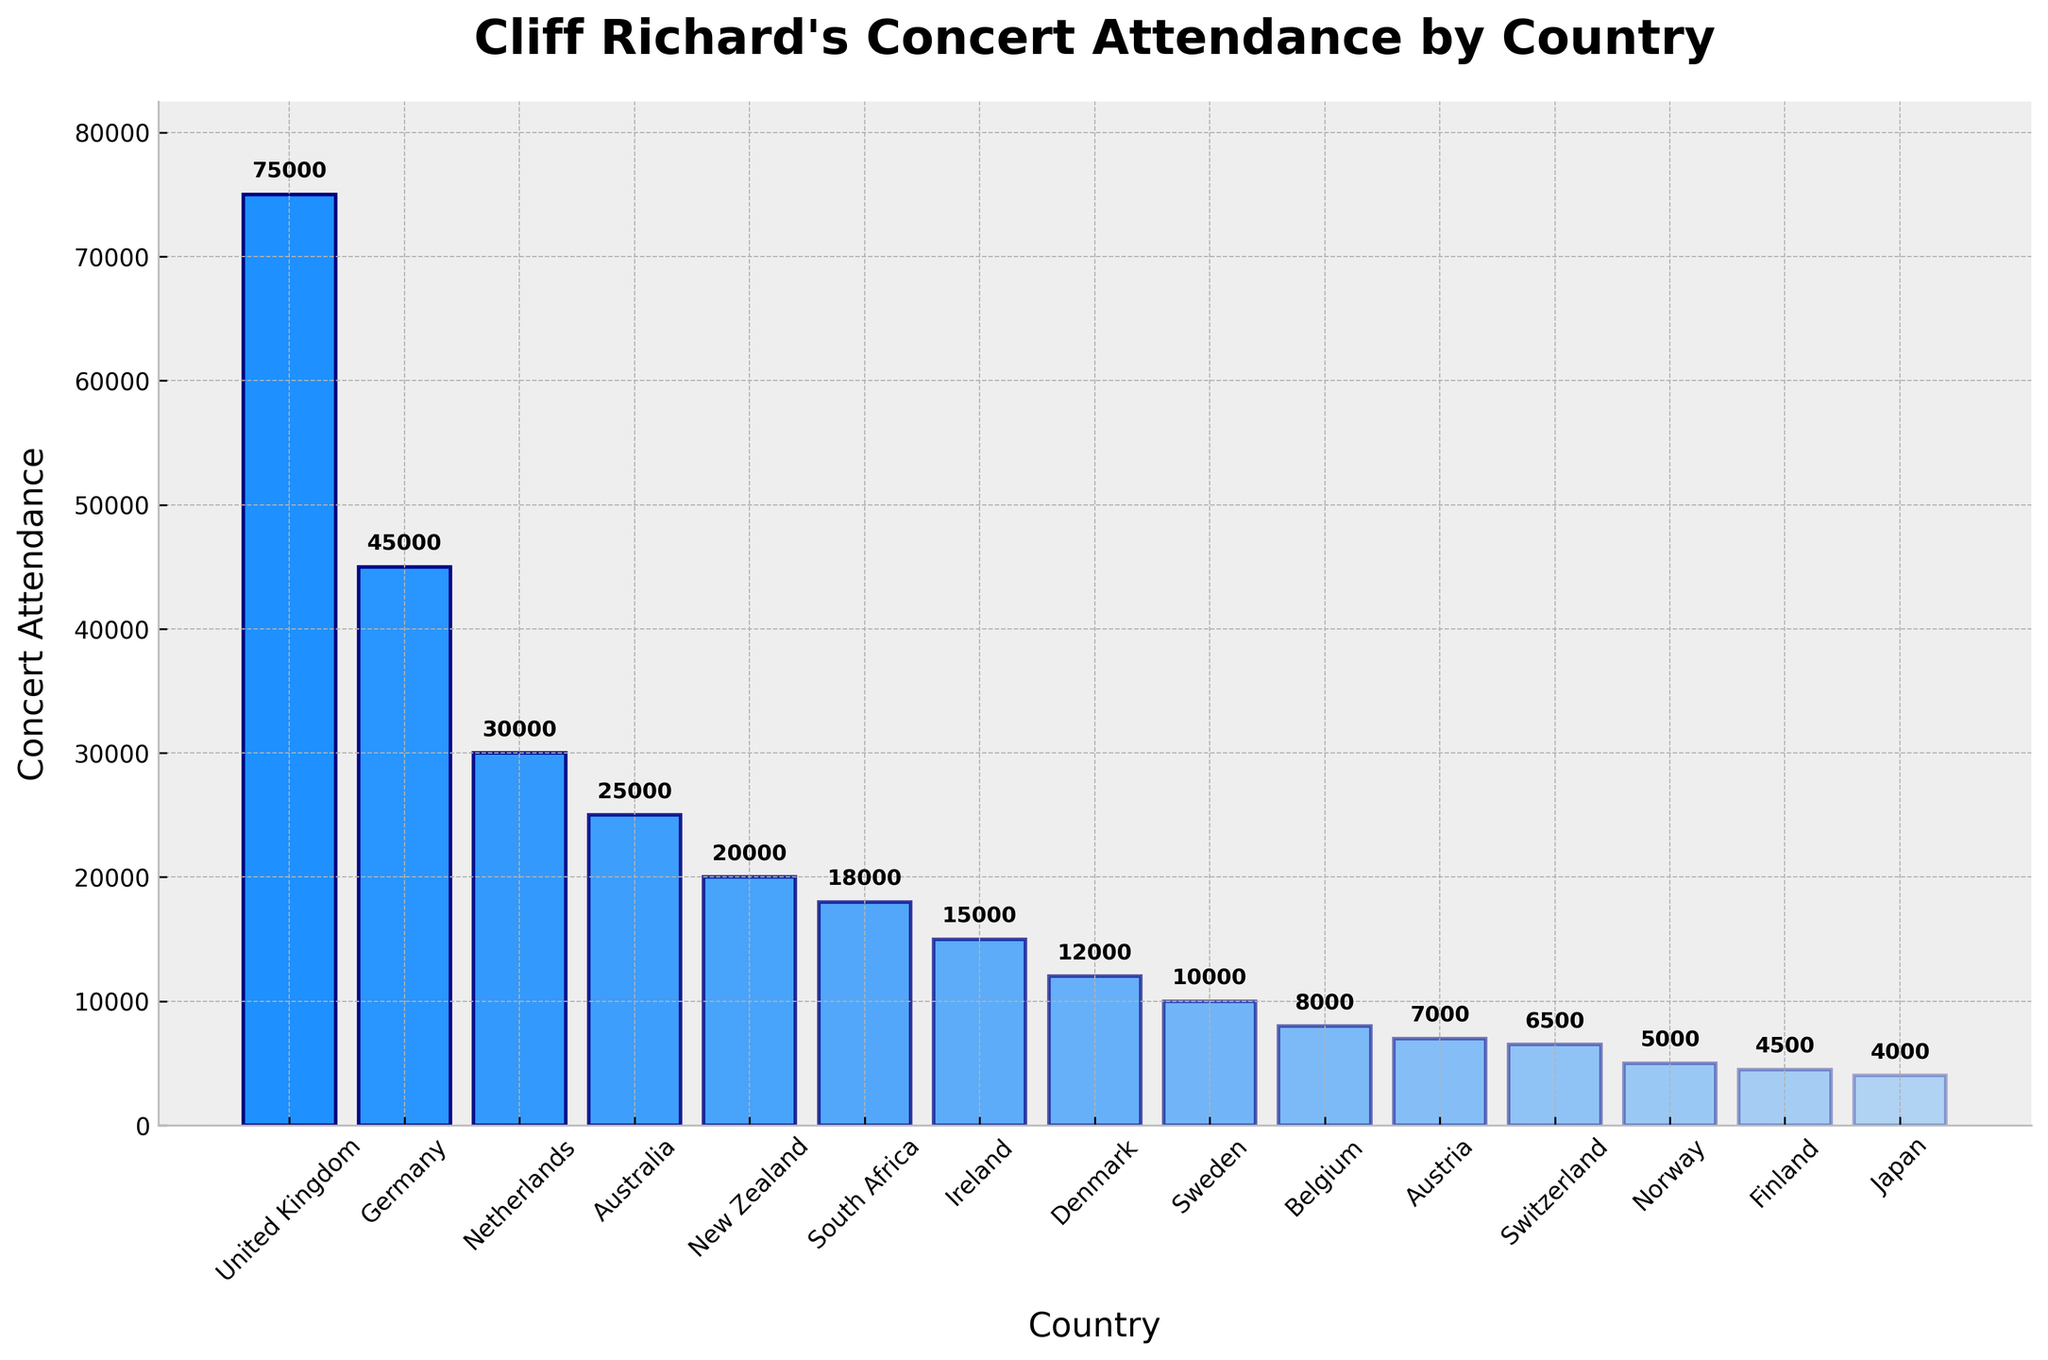what is the concert attendance difference between the United Kingdom and Germany? The concert attendance in the United Kingdom is 75,000, while in Germany it is 45,000. Subtracting the German attendance from the UK attendance gives 75,000 - 45,000 = 30,000
Answer: 30,000 which country has the lowest concert attendance for Cliff Richard? The country with the lowest concert attendance is Japan, with 4,000 attendees
Answer: Japan what is the total concert attendance in Australia, New Zealand, and South Africa combined? Summing the attendance figures for Australia (25,000), New Zealand (20,000), and South Africa (18,000) results in 25,000 + 20,000 + 18,000 = 63,000
Answer: 63,000 how does the concert attendance in Ireland compare to that in Denmark? The concert attendance in Ireland is 15,000, while in Denmark it is 12,000. Ireland's attendance is 3,000 more than Denmark's
Answer: 3,000 what is the average concert attendance for the top three countries? The top three countries by attendance are the United Kingdom (75,000), Germany (45,000), and the Netherlands (30,000). The average is (75,000 + 45,000 + 30,000) / 3 = 150,000 / 3 = 50,000
Answer: 50,000 how many countries have a concert attendance of 10,000 or less? The countries with a concert attendance of 10,000 or less are Sweden (10,000), Belgium (8,000), Austria (7,000), Switzerland (6,500), Norway (5,000), Finland (4,500), and Japan (4,000). There are 7 such countries
Answer: 7 which country has just 2000 more concert attendance than New Zealand? New Zealand has a concert attendance of 20,000 and Australia has an attendance of 25,000, which is 2,000 more than New Zealand's
Answer: Australia what is the visual difference in bar heights between Belgium and Austria? Belgium has a concert attendance of 8,000 while Austria has 7,000. The bar representing Belgium is taller by 1,000 units compared to Austria's
Answer: 1,000 